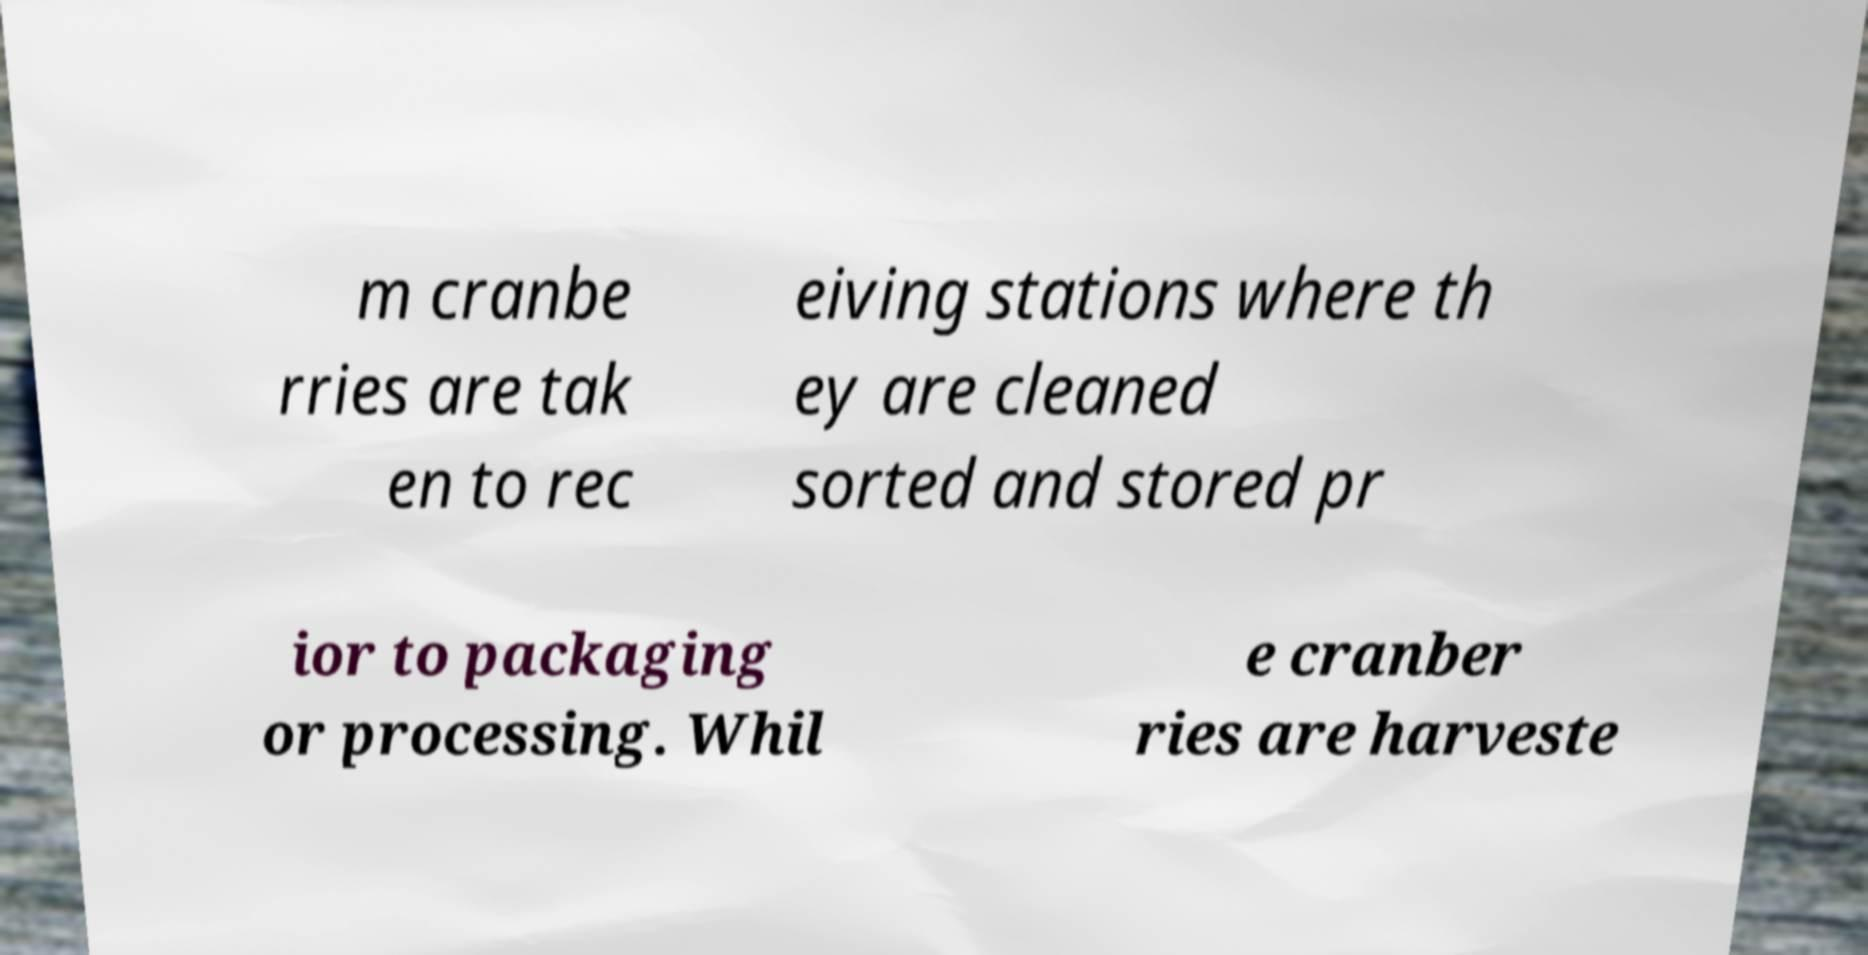I need the written content from this picture converted into text. Can you do that? m cranbe rries are tak en to rec eiving stations where th ey are cleaned sorted and stored pr ior to packaging or processing. Whil e cranber ries are harveste 